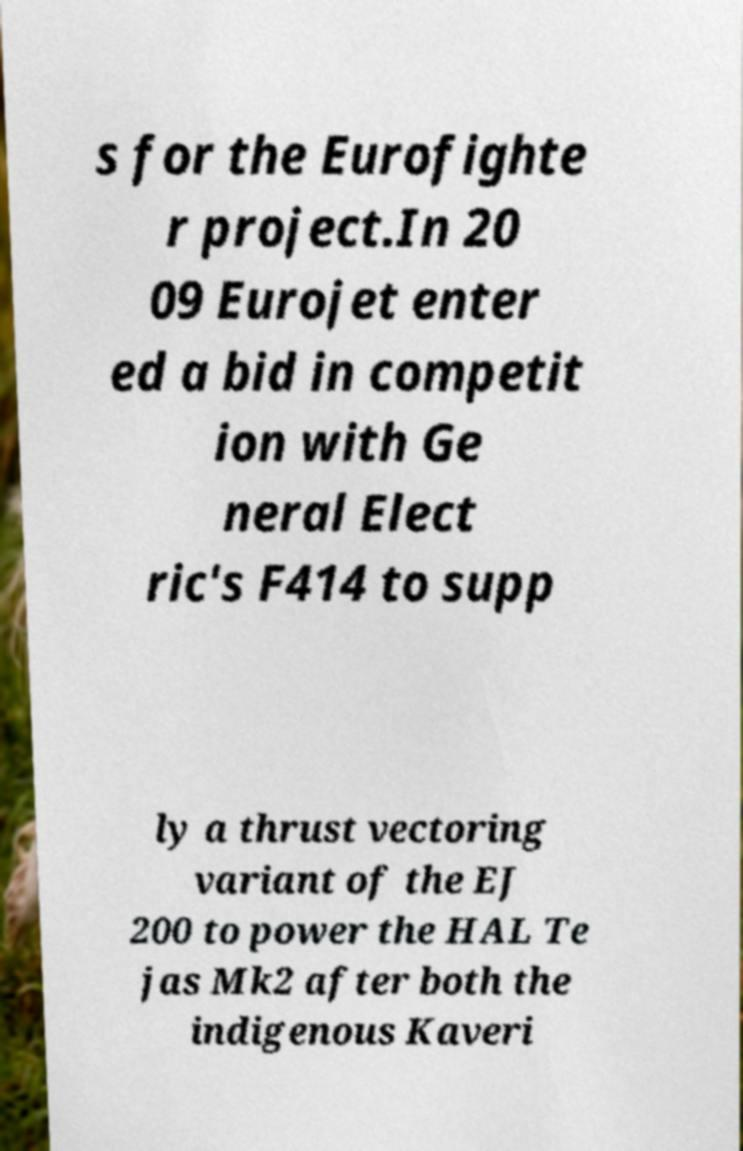For documentation purposes, I need the text within this image transcribed. Could you provide that? s for the Eurofighte r project.In 20 09 Eurojet enter ed a bid in competit ion with Ge neral Elect ric's F414 to supp ly a thrust vectoring variant of the EJ 200 to power the HAL Te jas Mk2 after both the indigenous Kaveri 